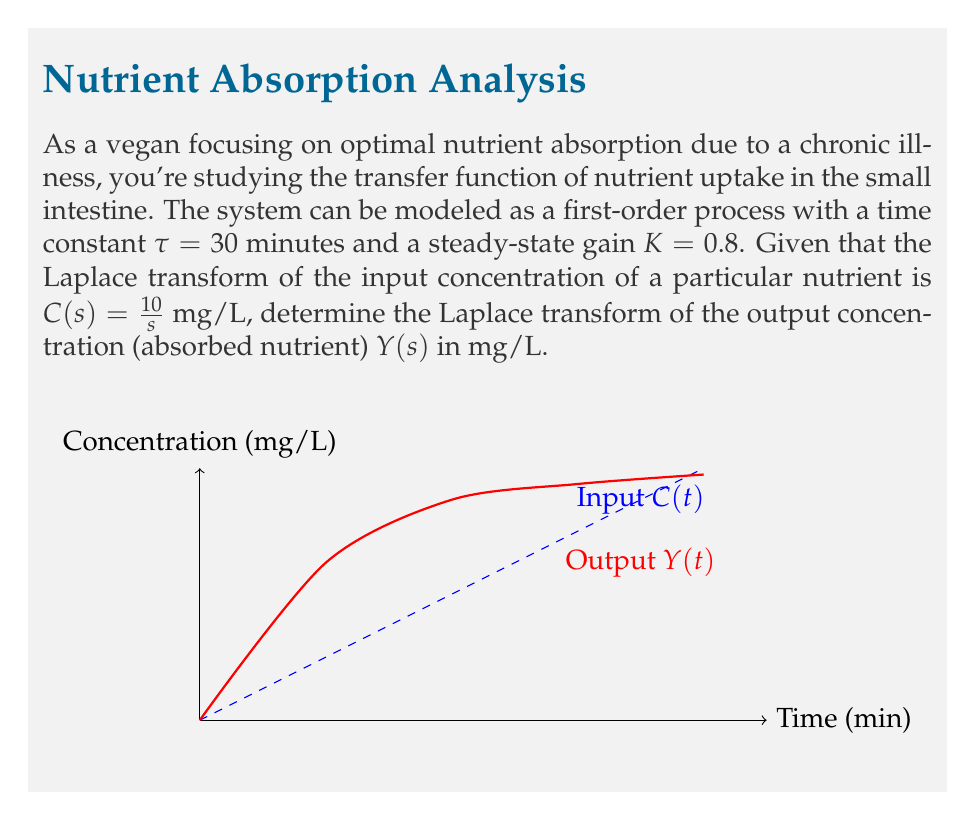What is the answer to this math problem? Let's approach this step-by-step:

1) The transfer function of a first-order system is given by:

   $$G(s) = \frac{K}{\tau s + 1}$$

   Where K is the steady-state gain and τ is the time constant.

2) Given the information:
   K = 0.8
   τ = 30 minutes

3) Substituting these values into the transfer function:

   $$G(s) = \frac{0.8}{30s + 1}$$

4) The relationship between input and output in the Laplace domain is:

   $$Y(s) = G(s) \cdot C(s)$$

5) We're given that $C(s) = \frac{10}{s}$ mg/L

6) Now, let's substitute G(s) and C(s) into the equation:

   $$Y(s) = \frac{0.8}{30s + 1} \cdot \frac{10}{s}$$

7) Simplify:

   $$Y(s) = \frac{8}{s(30s + 1)}$$

8) This can be further simplified to:

   $$Y(s) = \frac{8}{30s^2 + s}$$

This is the Laplace transform of the output concentration (absorbed nutrient).
Answer: $Y(s) = \frac{8}{30s^2 + s}$ mg/L 